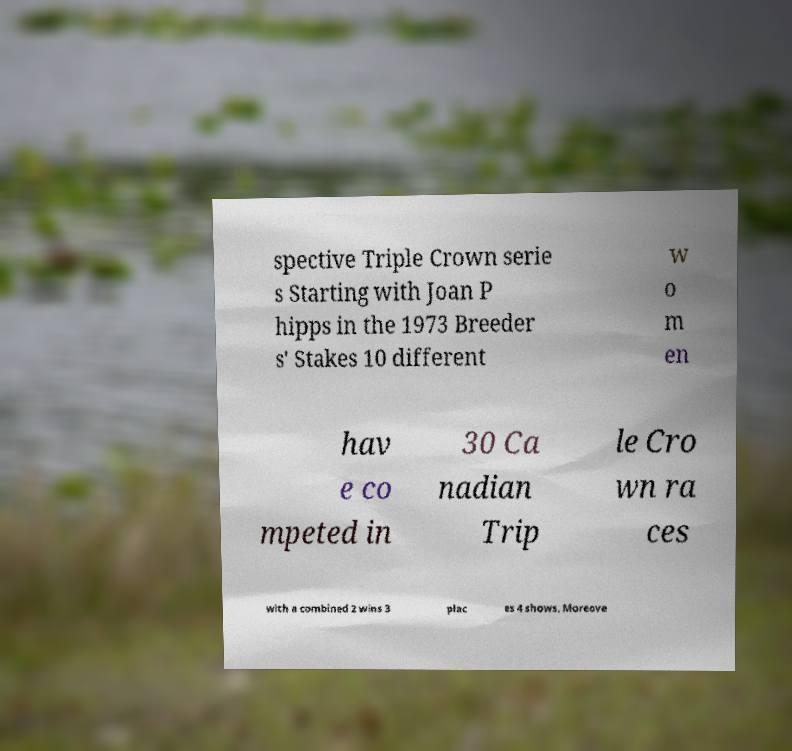I need the written content from this picture converted into text. Can you do that? spective Triple Crown serie s Starting with Joan P hipps in the 1973 Breeder s' Stakes 10 different w o m en hav e co mpeted in 30 Ca nadian Trip le Cro wn ra ces with a combined 2 wins 3 plac es 4 shows. Moreove 